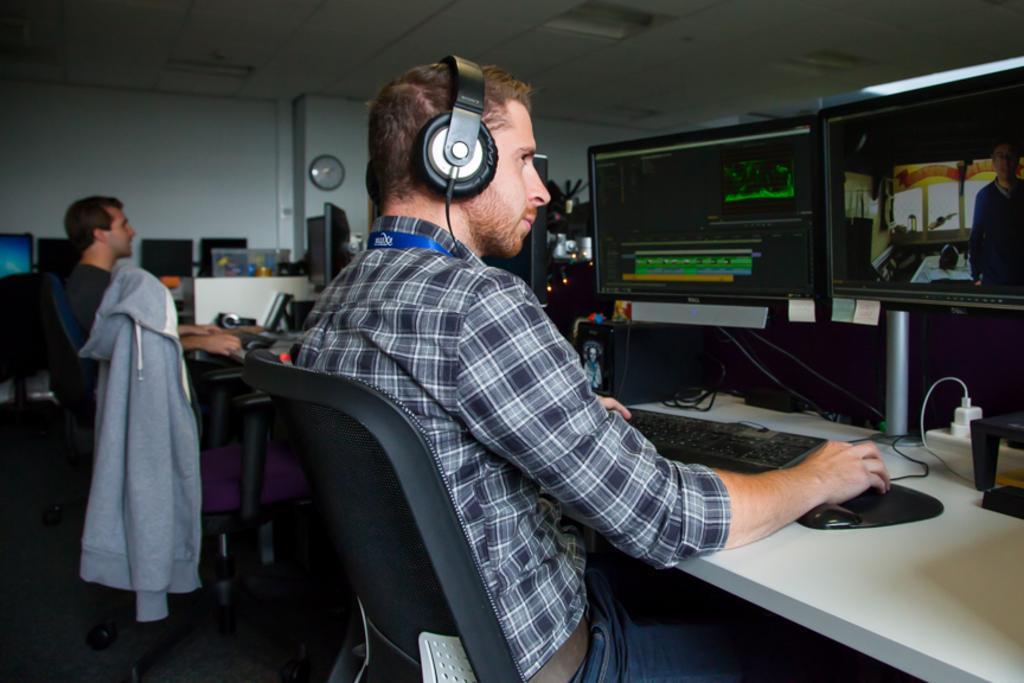Please provide a concise description of this image. This picture shows a man sitting in the chair in front of a computer, wearing a headset on his head. In the background there is another man, sitting and there is a wall clock attached to the wall here. 